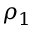Convert formula to latex. <formula><loc_0><loc_0><loc_500><loc_500>\rho _ { 1 }</formula> 